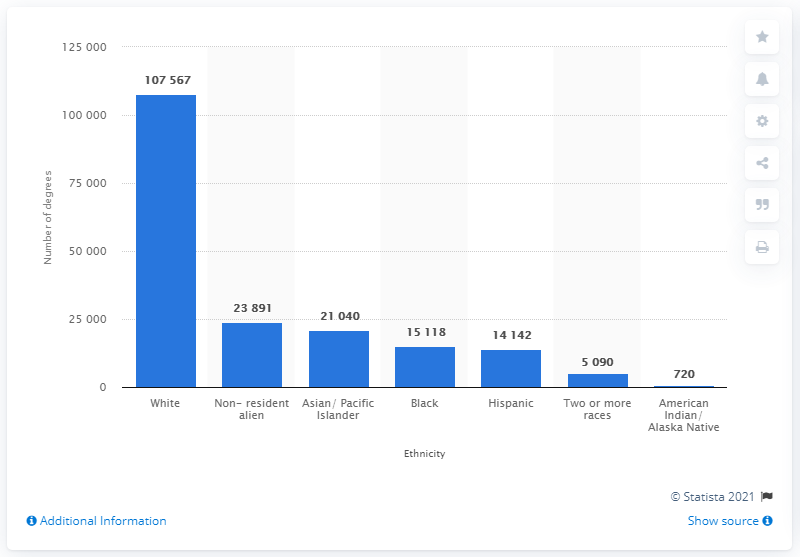Specify some key components in this picture. In the 2018/19 academic year, a total of 720 doctoral degrees were earned by American Indian or Alaskan Native students. 